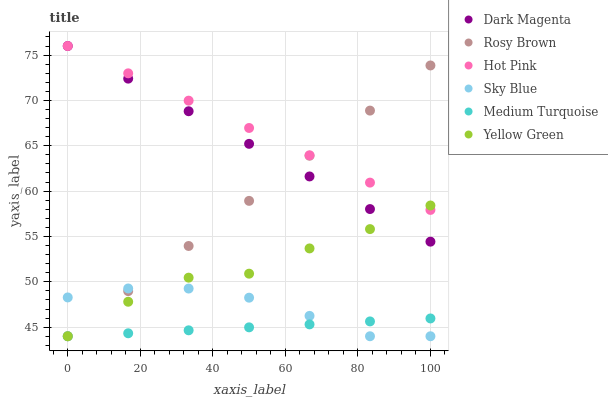Does Medium Turquoise have the minimum area under the curve?
Answer yes or no. Yes. Does Hot Pink have the maximum area under the curve?
Answer yes or no. Yes. Does Yellow Green have the minimum area under the curve?
Answer yes or no. No. Does Yellow Green have the maximum area under the curve?
Answer yes or no. No. Is Hot Pink the smoothest?
Answer yes or no. Yes. Is Yellow Green the roughest?
Answer yes or no. Yes. Is Rosy Brown the smoothest?
Answer yes or no. No. Is Rosy Brown the roughest?
Answer yes or no. No. Does Yellow Green have the lowest value?
Answer yes or no. Yes. Does Dark Magenta have the lowest value?
Answer yes or no. No. Does Dark Magenta have the highest value?
Answer yes or no. Yes. Does Yellow Green have the highest value?
Answer yes or no. No. Is Medium Turquoise less than Hot Pink?
Answer yes or no. Yes. Is Hot Pink greater than Medium Turquoise?
Answer yes or no. Yes. Does Medium Turquoise intersect Yellow Green?
Answer yes or no. Yes. Is Medium Turquoise less than Yellow Green?
Answer yes or no. No. Is Medium Turquoise greater than Yellow Green?
Answer yes or no. No. Does Medium Turquoise intersect Hot Pink?
Answer yes or no. No. 